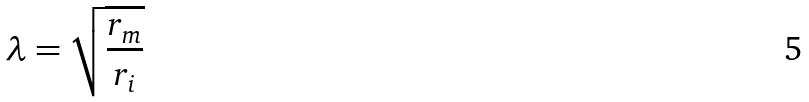Convert formula to latex. <formula><loc_0><loc_0><loc_500><loc_500>\lambda = \sqrt { \frac { r _ { m } } { r _ { i } } }</formula> 